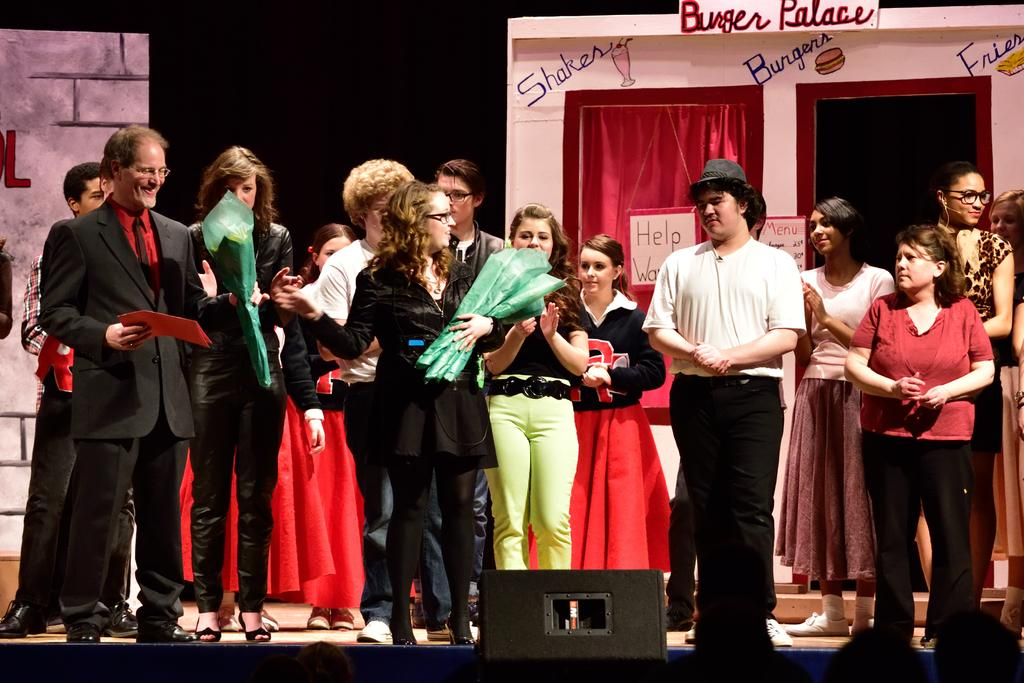What is happening in the image? There is a group of people standing on a stage. What are the people holding? Some people in the group are holding objects. What can be seen in the background of the image? There is a dramatic setting behind the group of people. What type of cheese is being used to increase the size of the insects in the image? There is no cheese, insects, or any indication of size increase in the image. 